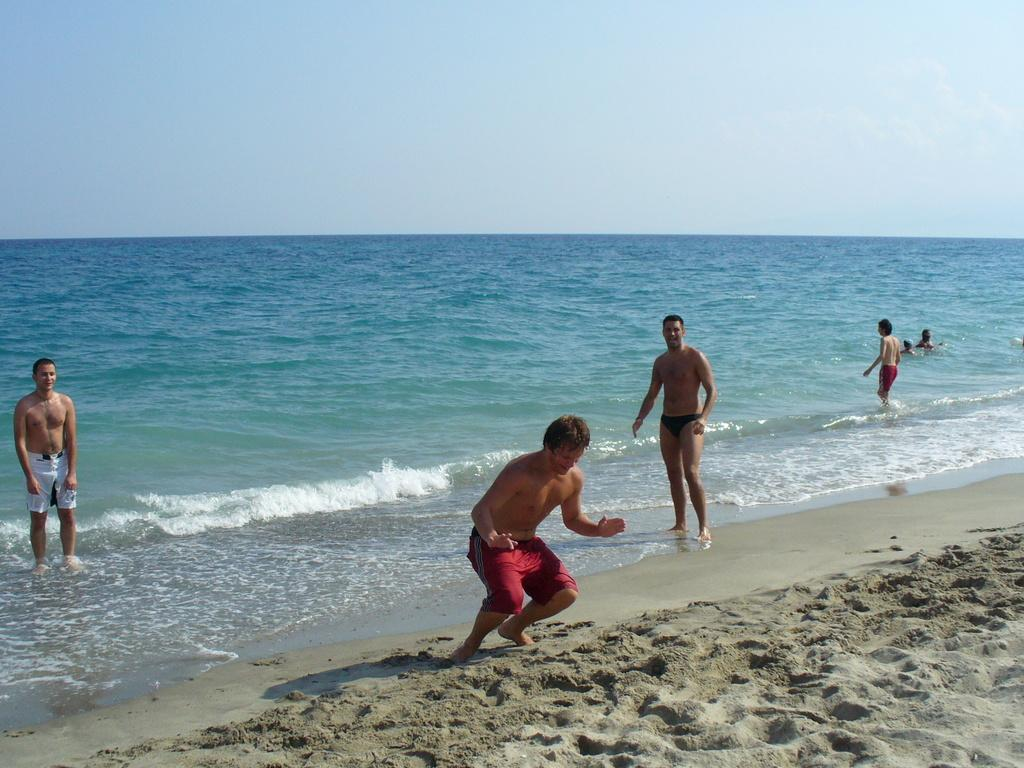Who or what can be seen in the image? There are people in the image. What type of terrain is visible in the image? There is sand and water visible in the image. What can be seen in the background of the image? The sky is visible in the background of the image. What type of copper needle is being used by the people in the image? There is no copper needle present in the image; it features people, sand, water, and a visible sky. 